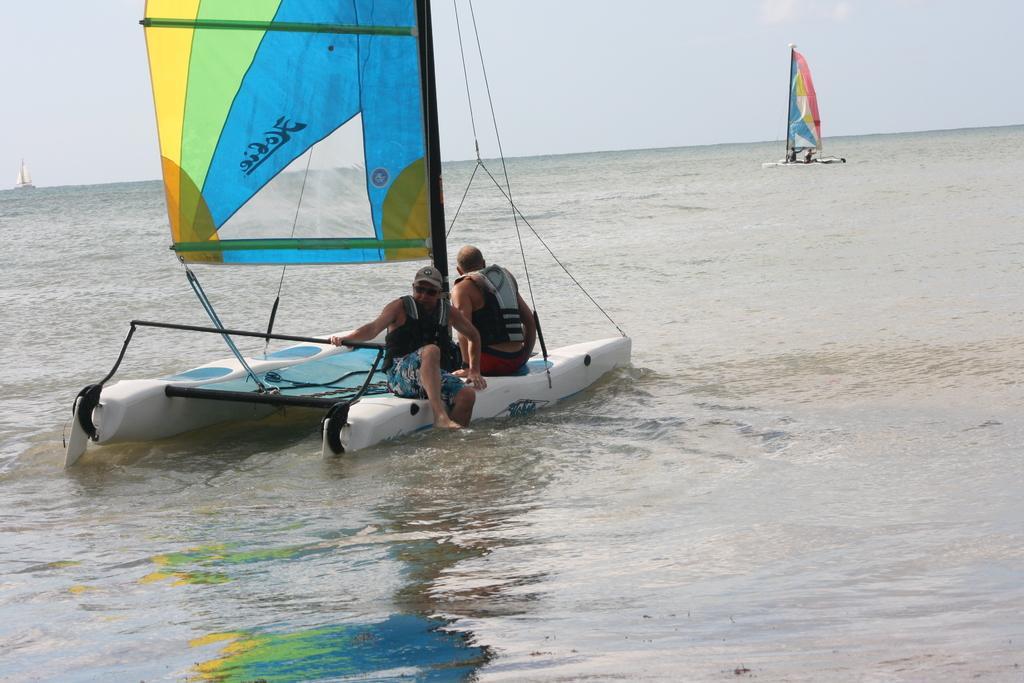Can you describe this image briefly? In the picture we can see a boat in the water with a pole and two men are sitting on it with live jackets and far away from it, we can see another boat with a pole on it and in the background we can see the sky. 